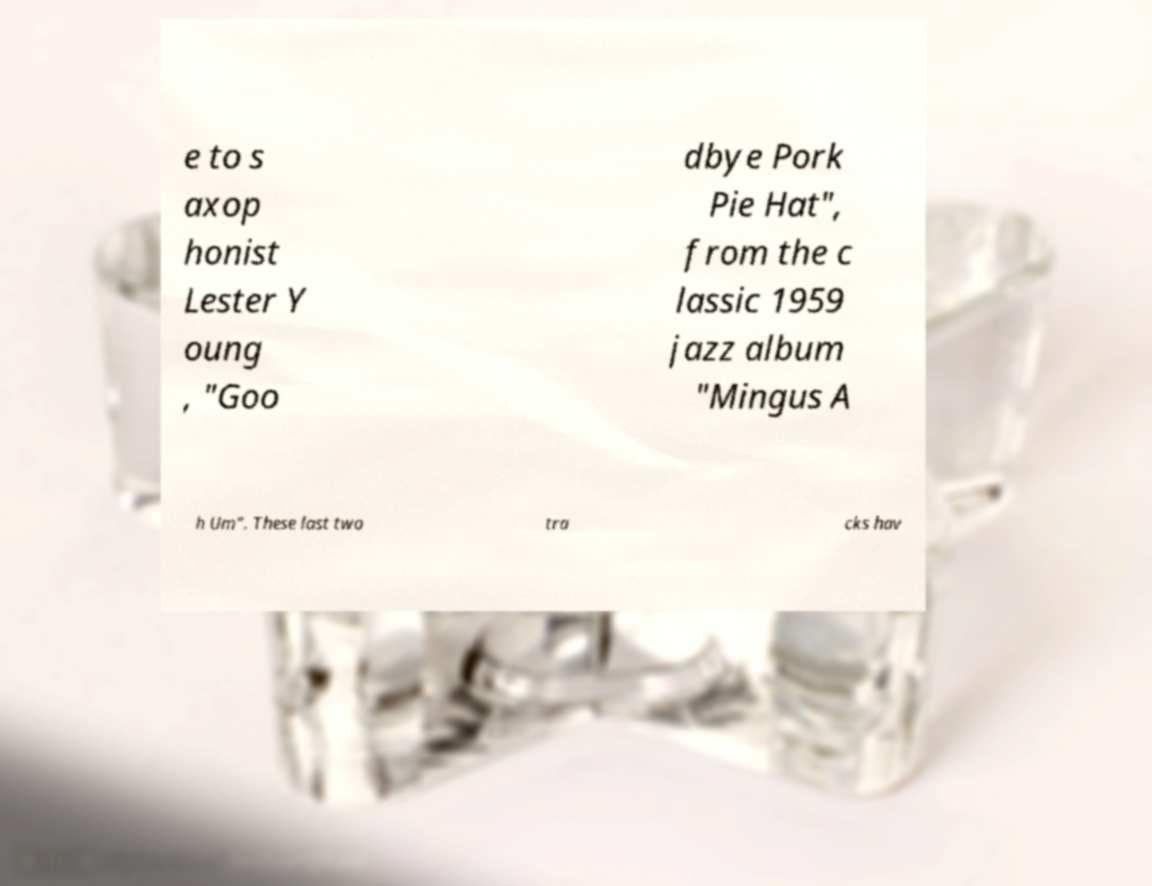What messages or text are displayed in this image? I need them in a readable, typed format. e to s axop honist Lester Y oung , "Goo dbye Pork Pie Hat", from the c lassic 1959 jazz album "Mingus A h Um". These last two tra cks hav 